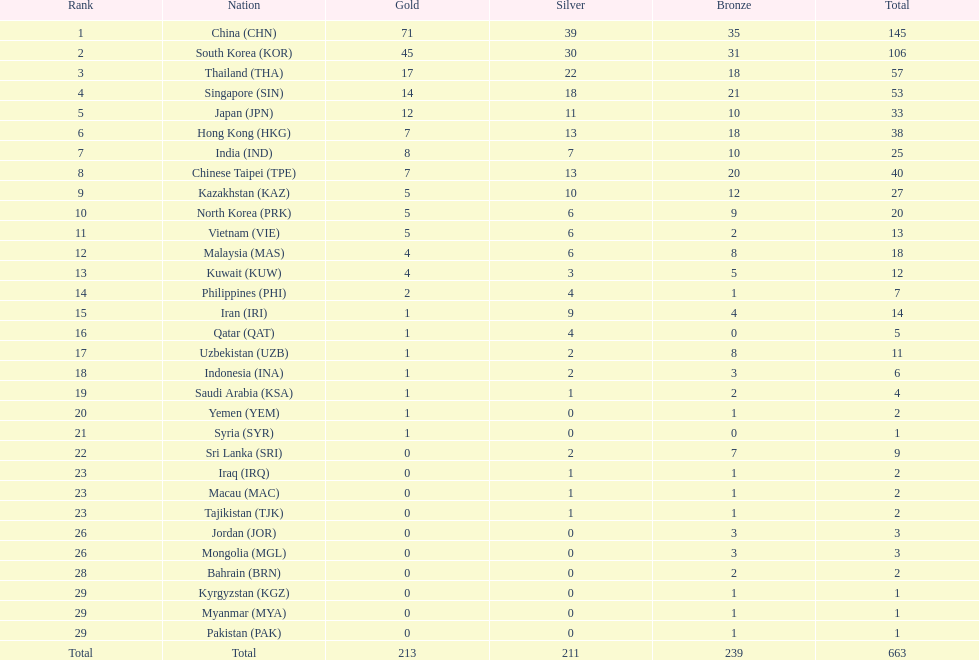How many gold medals are required for qatar to achieve a total count of 12 gold medals? 11. 